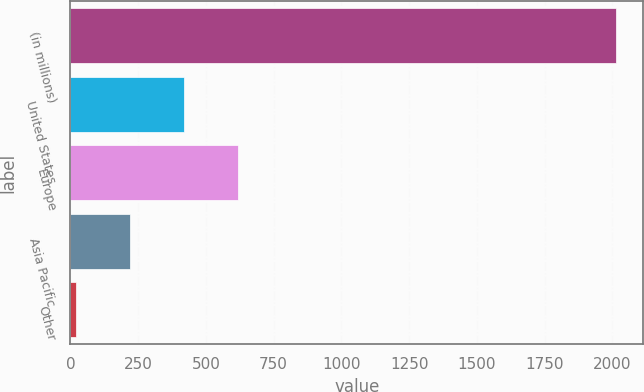<chart> <loc_0><loc_0><loc_500><loc_500><bar_chart><fcel>(in millions)<fcel>United States<fcel>Europe<fcel>Asia Pacific<fcel>Other<nl><fcel>2014<fcel>420.4<fcel>619.6<fcel>221.2<fcel>22<nl></chart> 